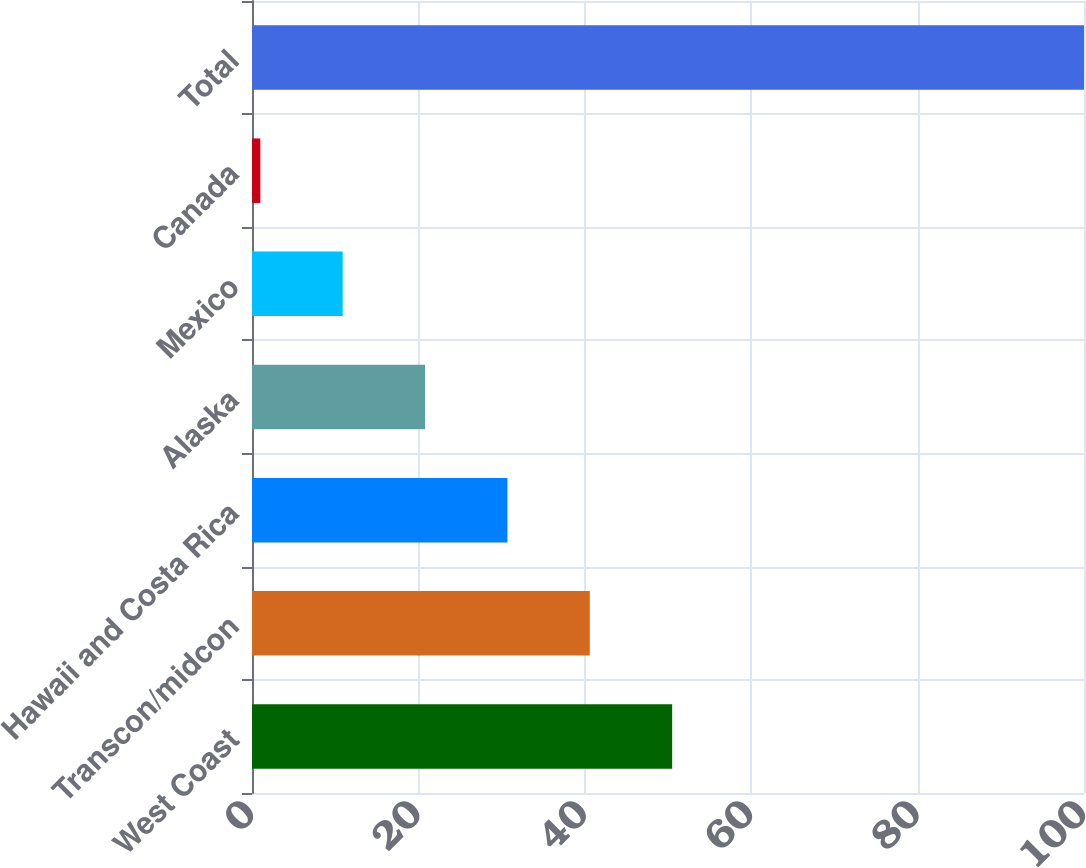Convert chart. <chart><loc_0><loc_0><loc_500><loc_500><bar_chart><fcel>West Coast<fcel>Transcon/midcon<fcel>Hawaii and Costa Rica<fcel>Alaska<fcel>Mexico<fcel>Canada<fcel>Total<nl><fcel>50.5<fcel>40.6<fcel>30.7<fcel>20.8<fcel>10.9<fcel>1<fcel>100<nl></chart> 